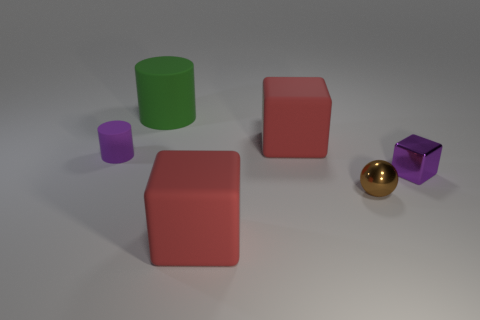Do the small purple cube and the big red thing behind the ball have the same material?
Ensure brevity in your answer.  No. What is the size of the shiny object that is the same color as the small cylinder?
Provide a short and direct response. Small. Is there a big red block made of the same material as the big cylinder?
Give a very brief answer. Yes. What color is the metallic block?
Offer a terse response. Purple. Does the thing right of the brown thing have the same shape as the small brown shiny thing?
Offer a very short reply. No. There is a small purple thing left of the rubber block in front of the purple thing on the left side of the purple metallic thing; what is its shape?
Your answer should be very brief. Cylinder. What is the material of the cylinder that is on the left side of the green cylinder?
Offer a very short reply. Rubber. The cylinder that is the same size as the metallic cube is what color?
Offer a terse response. Purple. What number of other objects are the same shape as the green thing?
Keep it short and to the point. 1. Does the purple matte cylinder have the same size as the brown shiny thing?
Give a very brief answer. Yes. 